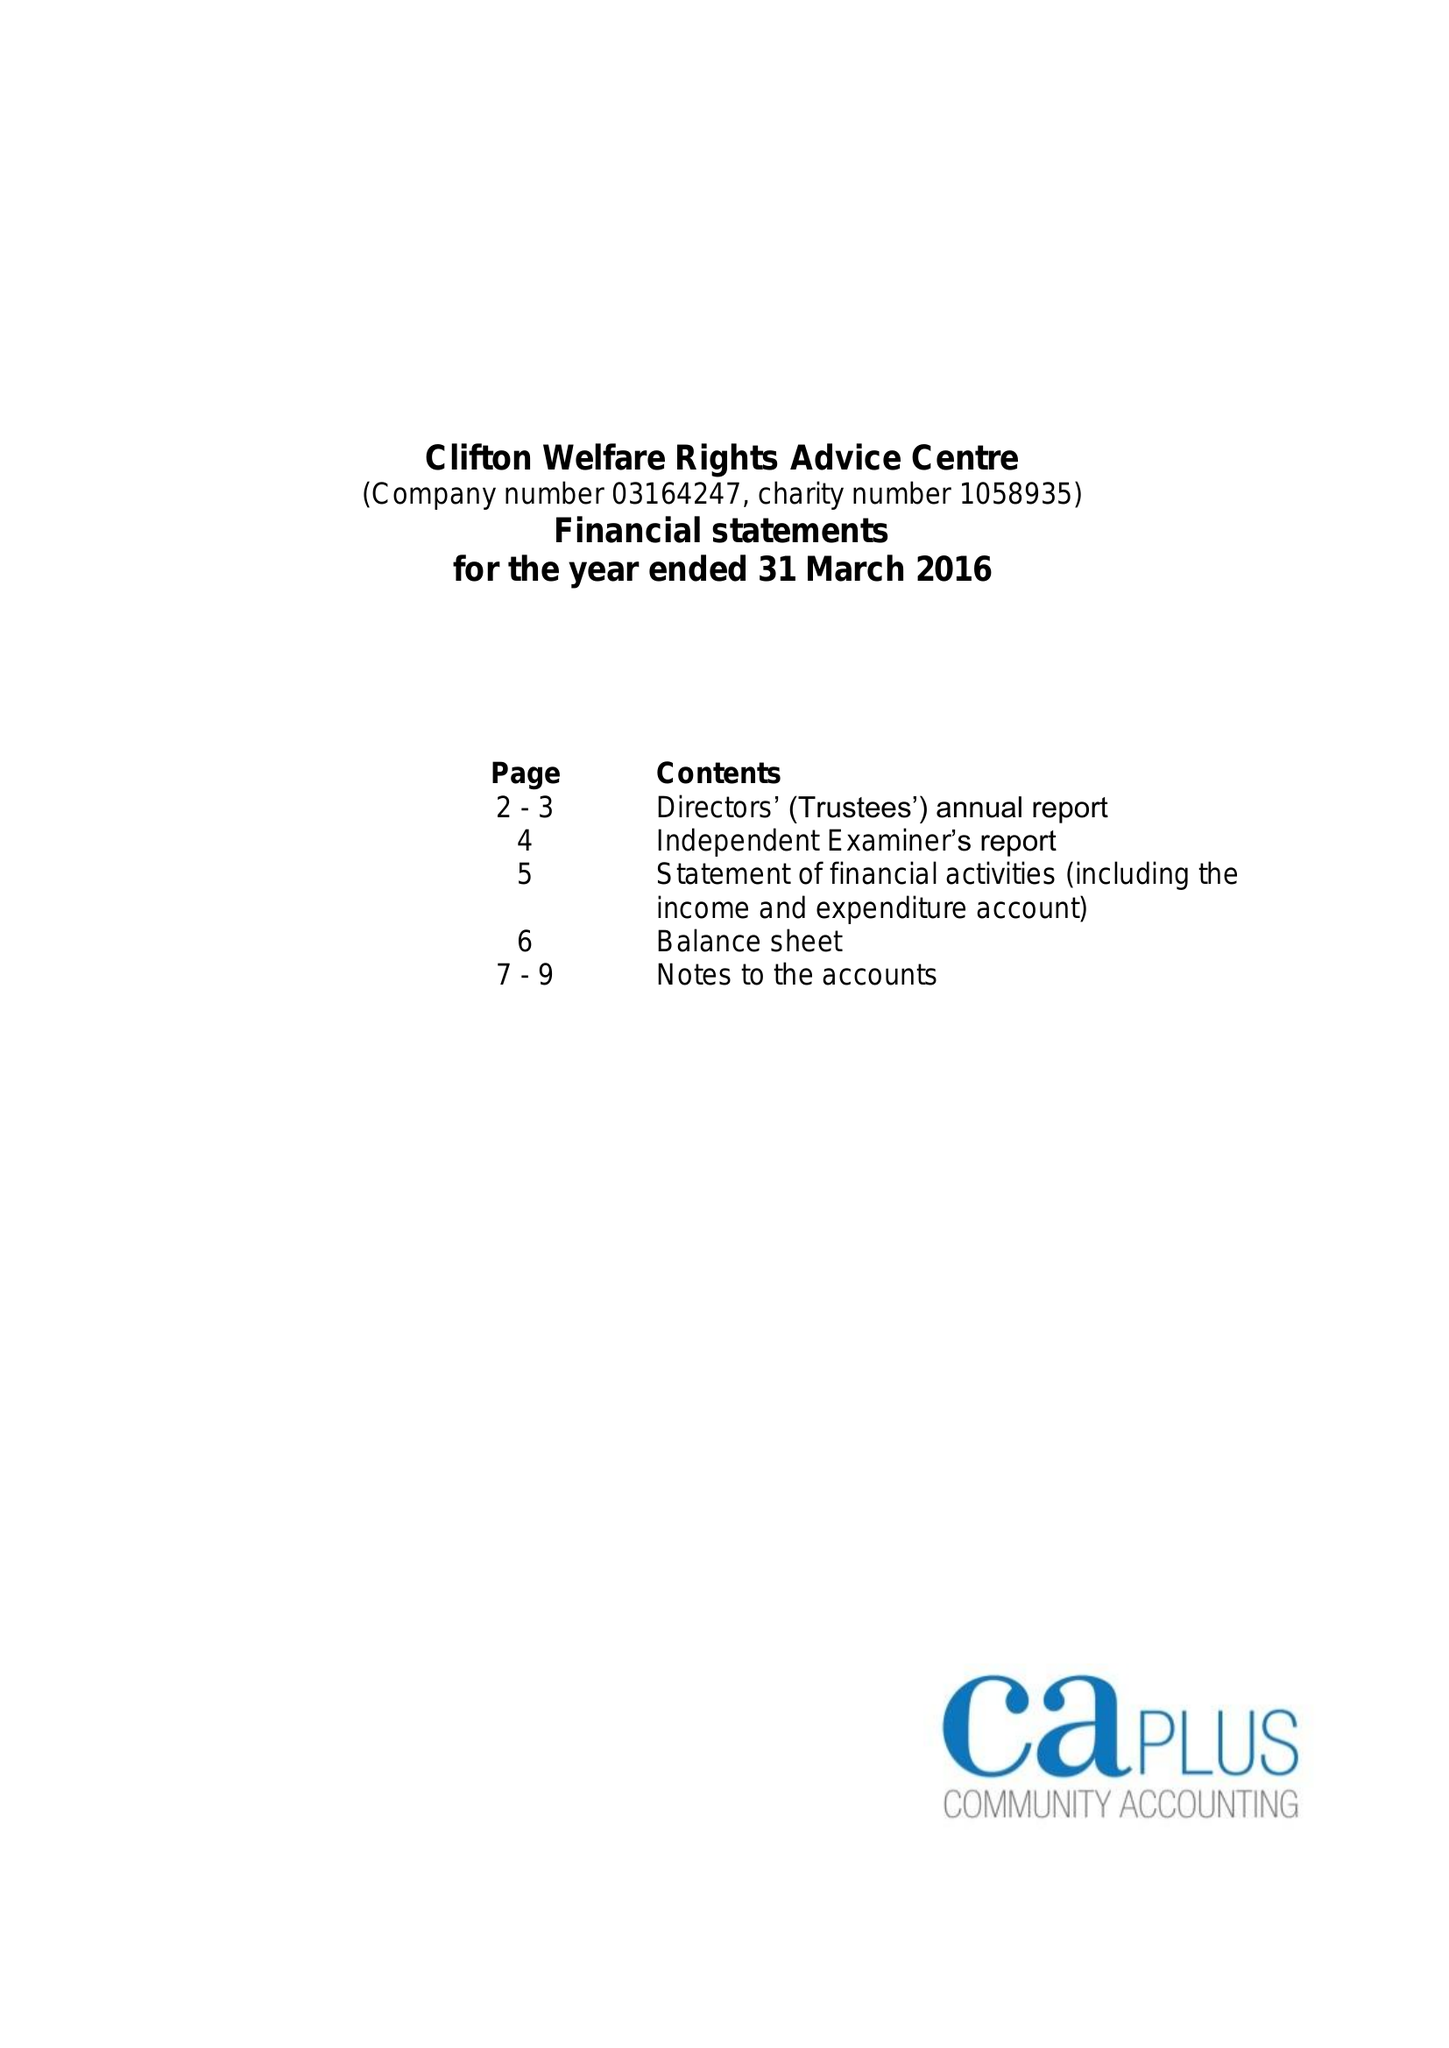What is the value for the address__post_town?
Answer the question using a single word or phrase. NOTTINGHAM 